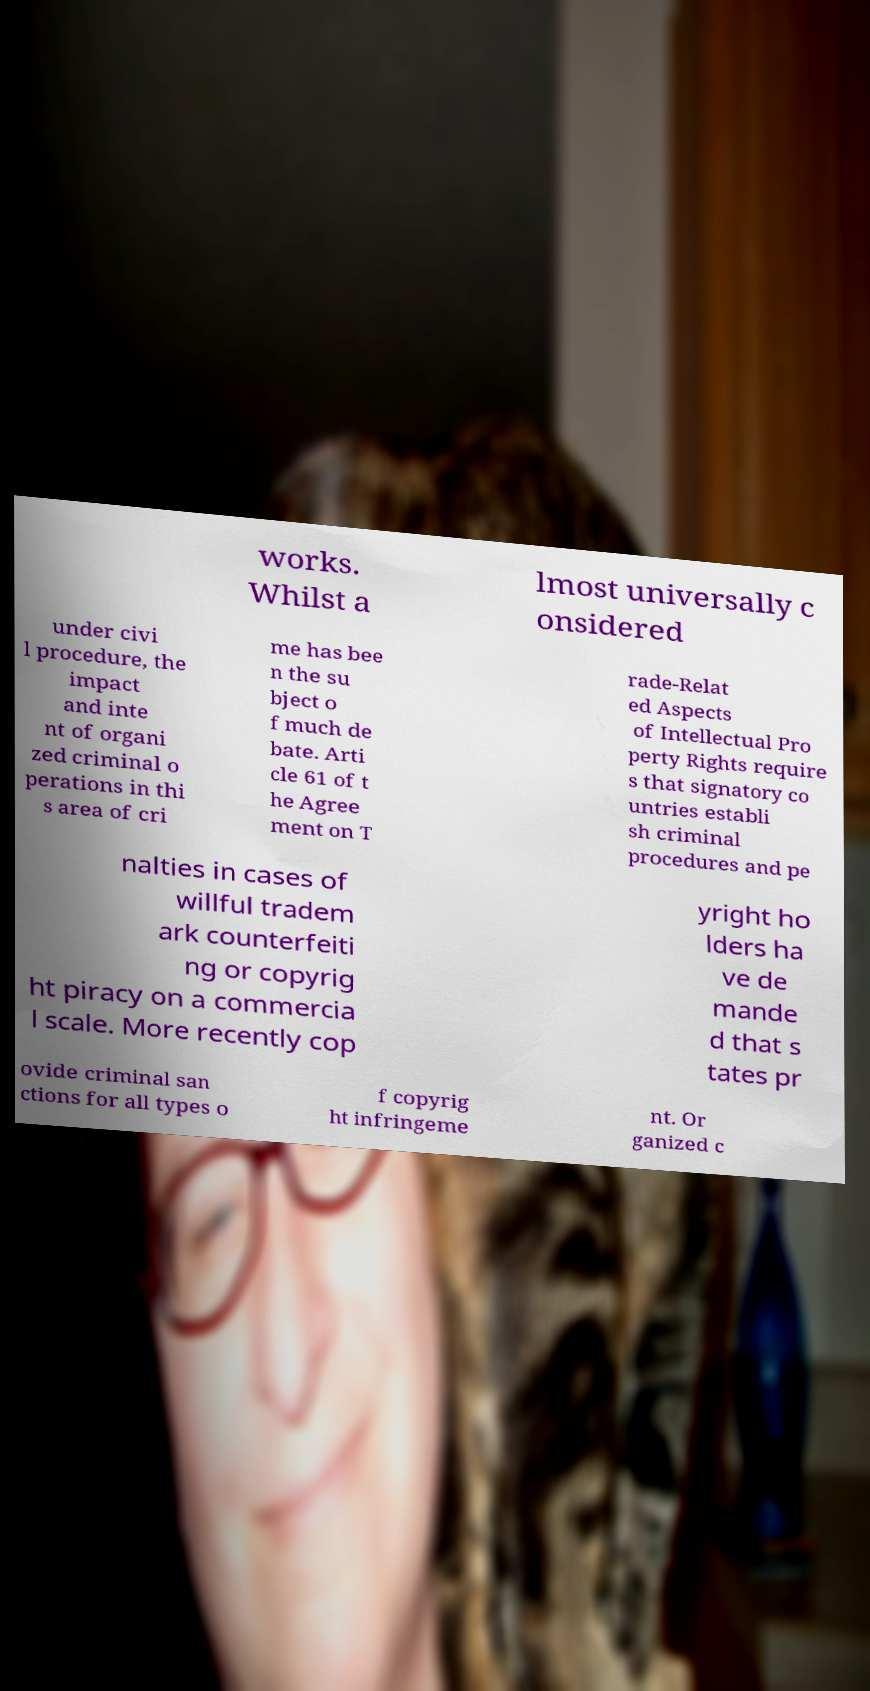I need the written content from this picture converted into text. Can you do that? works. Whilst a lmost universally c onsidered under civi l procedure, the impact and inte nt of organi zed criminal o perations in thi s area of cri me has bee n the su bject o f much de bate. Arti cle 61 of t he Agree ment on T rade-Relat ed Aspects of Intellectual Pro perty Rights require s that signatory co untries establi sh criminal procedures and pe nalties in cases of willful tradem ark counterfeiti ng or copyrig ht piracy on a commercia l scale. More recently cop yright ho lders ha ve de mande d that s tates pr ovide criminal san ctions for all types o f copyrig ht infringeme nt. Or ganized c 